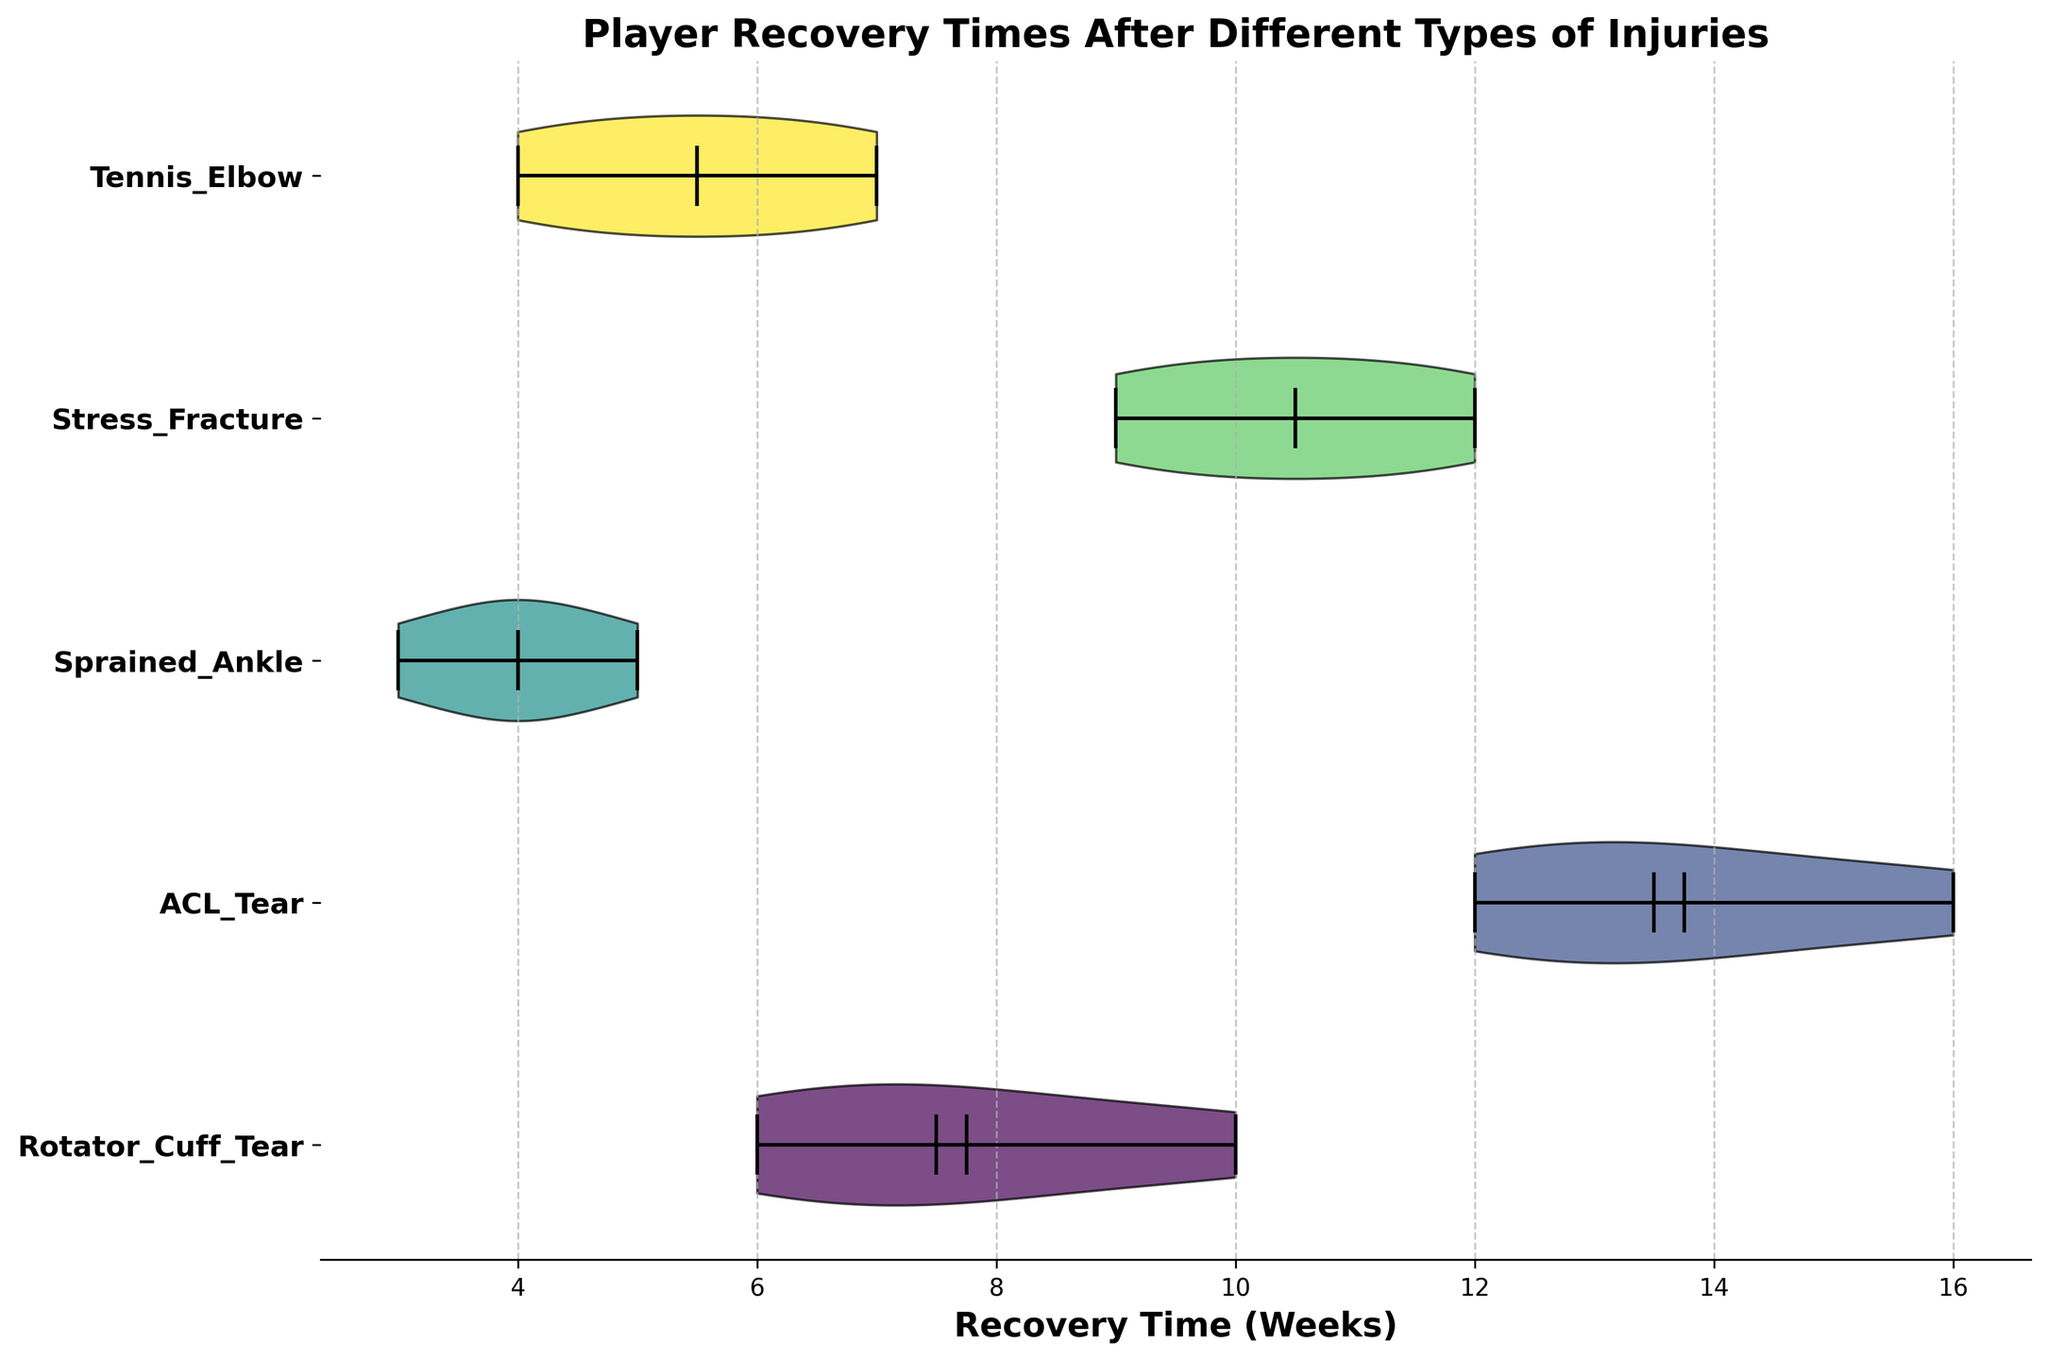What's the title of the figure? The title of the figure is usually located at the top of the chart. By looking at the chart, you can see the large text at the top, which serves as the title.
Answer: Player Recovery Times After Different Types of Injuries Which injury type has the widest range of recovery times? To determine the widest range, observe the horizontal length of each violin. The injury with the most extended horizontal spread indicates the largest range.
Answer: ACL Tear What is the median recovery time for a Rotator Cuff Tear? The median in a violin chart is often marked by a distinct line within the violin. Look for this line within the Rotator Cuff Tear violin to see where it aligns on the x-axis, which represents time.
Answer: 7.5 weeks How does the average recovery time for a Tennis Elbow compare to that of a Stress Fracture? Note the horizontal lines in each violin that mark the average (mean) time. Compare the positions of these lines for the Tennis Elbow and Stress Fracture violins along the x-axis.
Answer: Tennis Elbow is shorter Which injury type typically has the shortest recovery time? To find the shortest recovery time, look for the violin that is positioned the furthest to the left on the x-axis, representing fewer weeks.
Answer: Sprained Ankle How many injury types show recovery times that reach at least 10 weeks? Observe each violin and count those that extend to or past the 10-week mark on the x-axis.
Answer: Three (Rotator Cuff Tear, ACL Tear, Stress Fracture) What's the highest recovery time shown for a Rotator Cuff Tear? The highest recovery time will be represented by the furthest right point of the Rotator Cuff Tear violin on the x-axis.
Answer: 10 weeks Compare the mean recovery times of ACL Tear and Sprained Ankle. Which is higher? Identify the mean lines in each of the violins for ACL Tear and Sprained Ankle, then compare their positions on the x-axis to determine which is further to the right.
Answer: ACL Tear Which injury type has the most consistent recovery times? Consistency is indicated by a narrower spread within the violin shape. Look at the injuries with less horizontal spread (less width).
Answer: Sprained Ankle What does the shaded area around each injury type represent? In a violin plot, the shaded area represents the distribution of the data, showing where values are more or less concentrated.
Answer: Distribution of recovery times 